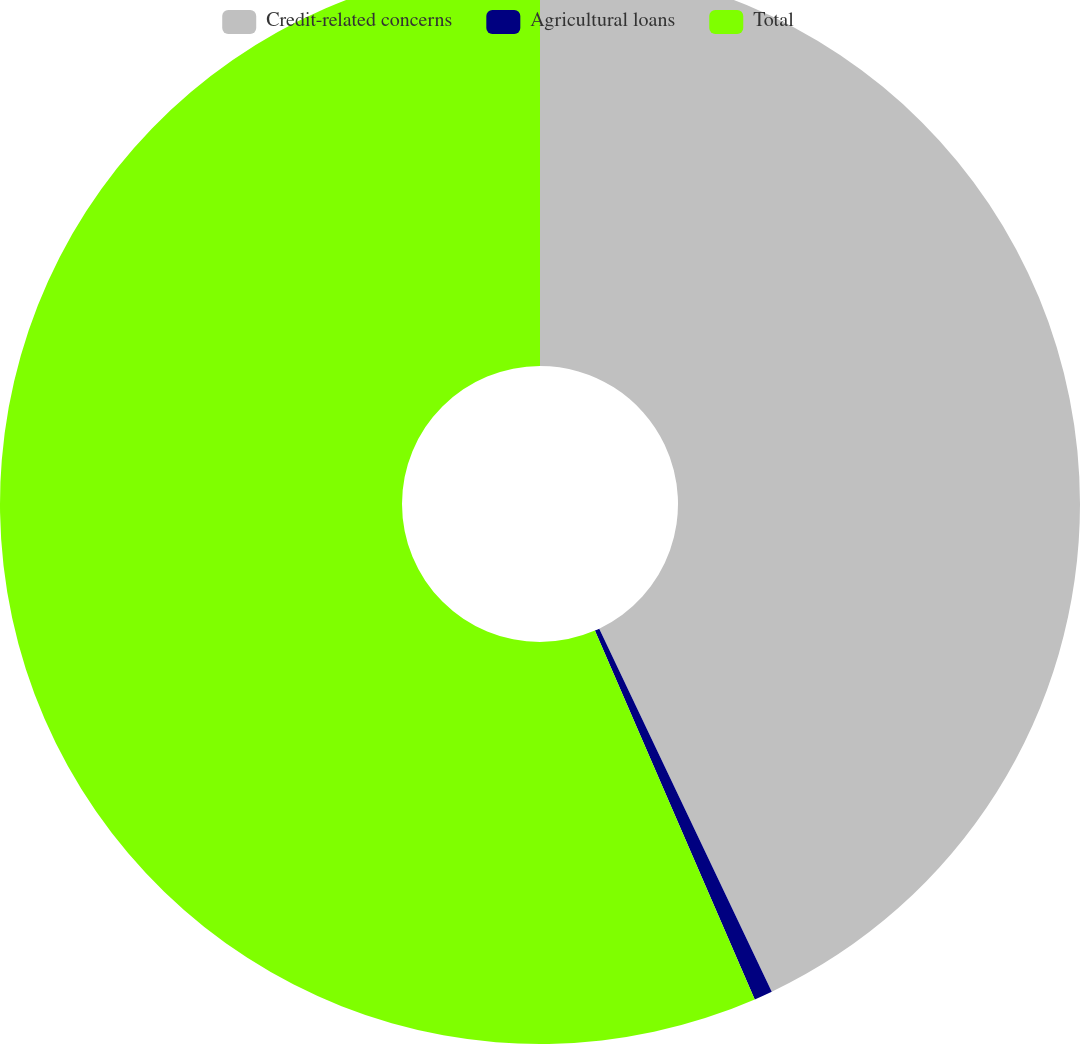Convert chart. <chart><loc_0><loc_0><loc_500><loc_500><pie_chart><fcel>Credit-related concerns<fcel>Agricultural loans<fcel>Total<nl><fcel>42.94%<fcel>0.55%<fcel>56.51%<nl></chart> 